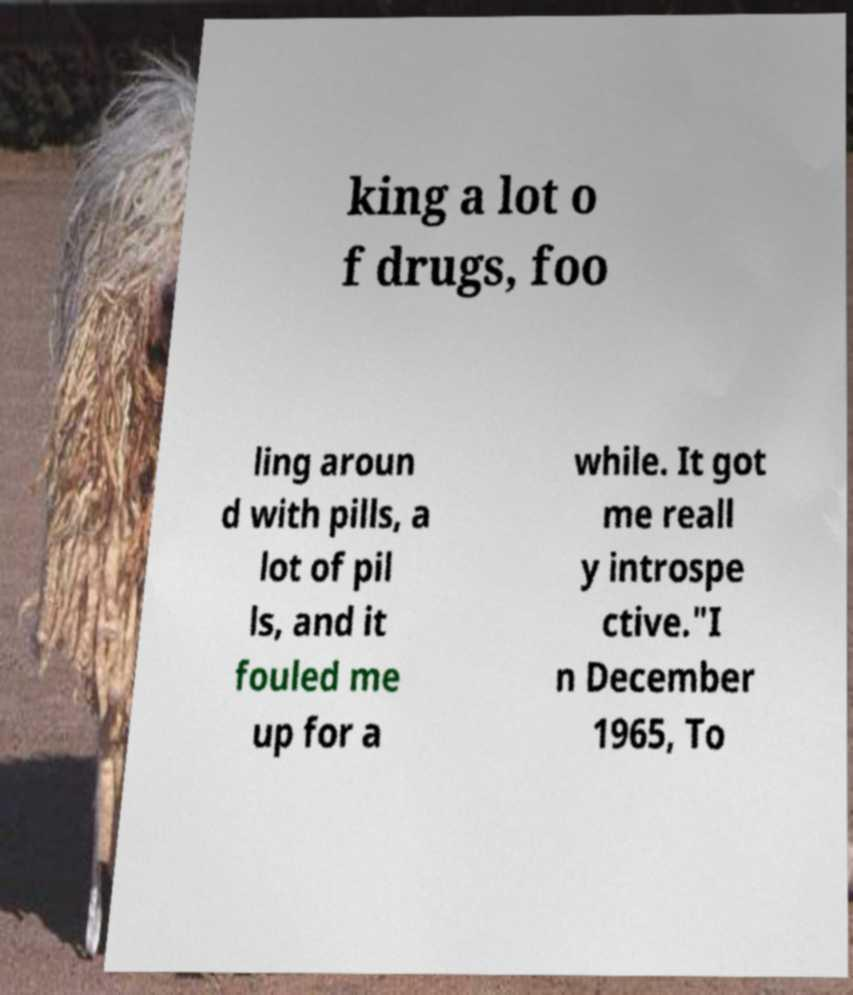For documentation purposes, I need the text within this image transcribed. Could you provide that? king a lot o f drugs, foo ling aroun d with pills, a lot of pil ls, and it fouled me up for a while. It got me reall y introspe ctive."I n December 1965, To 